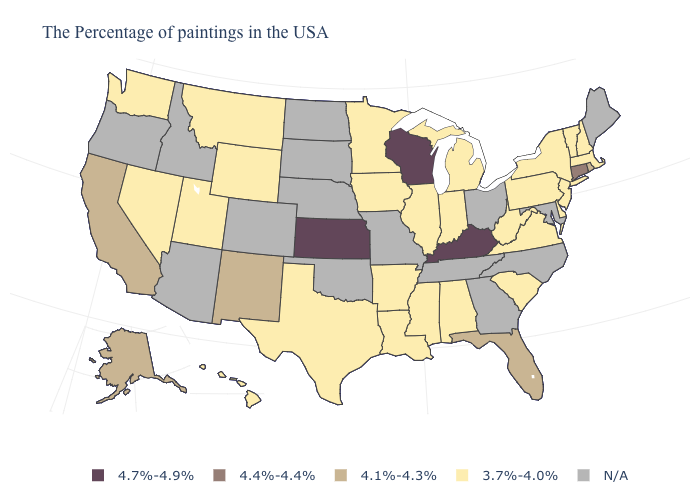Among the states that border New York , which have the highest value?
Quick response, please. Connecticut. Which states hav the highest value in the South?
Concise answer only. Kentucky. What is the value of Pennsylvania?
Answer briefly. 3.7%-4.0%. What is the value of Utah?
Quick response, please. 3.7%-4.0%. Does the map have missing data?
Short answer required. Yes. What is the highest value in the USA?
Be succinct. 4.7%-4.9%. Among the states that border Tennessee , which have the lowest value?
Short answer required. Virginia, Alabama, Mississippi, Arkansas. Does the map have missing data?
Write a very short answer. Yes. Is the legend a continuous bar?
Keep it brief. No. What is the lowest value in the West?
Write a very short answer. 3.7%-4.0%. What is the value of New Mexico?
Concise answer only. 4.1%-4.3%. Name the states that have a value in the range 4.4%-4.4%?
Concise answer only. Connecticut. 